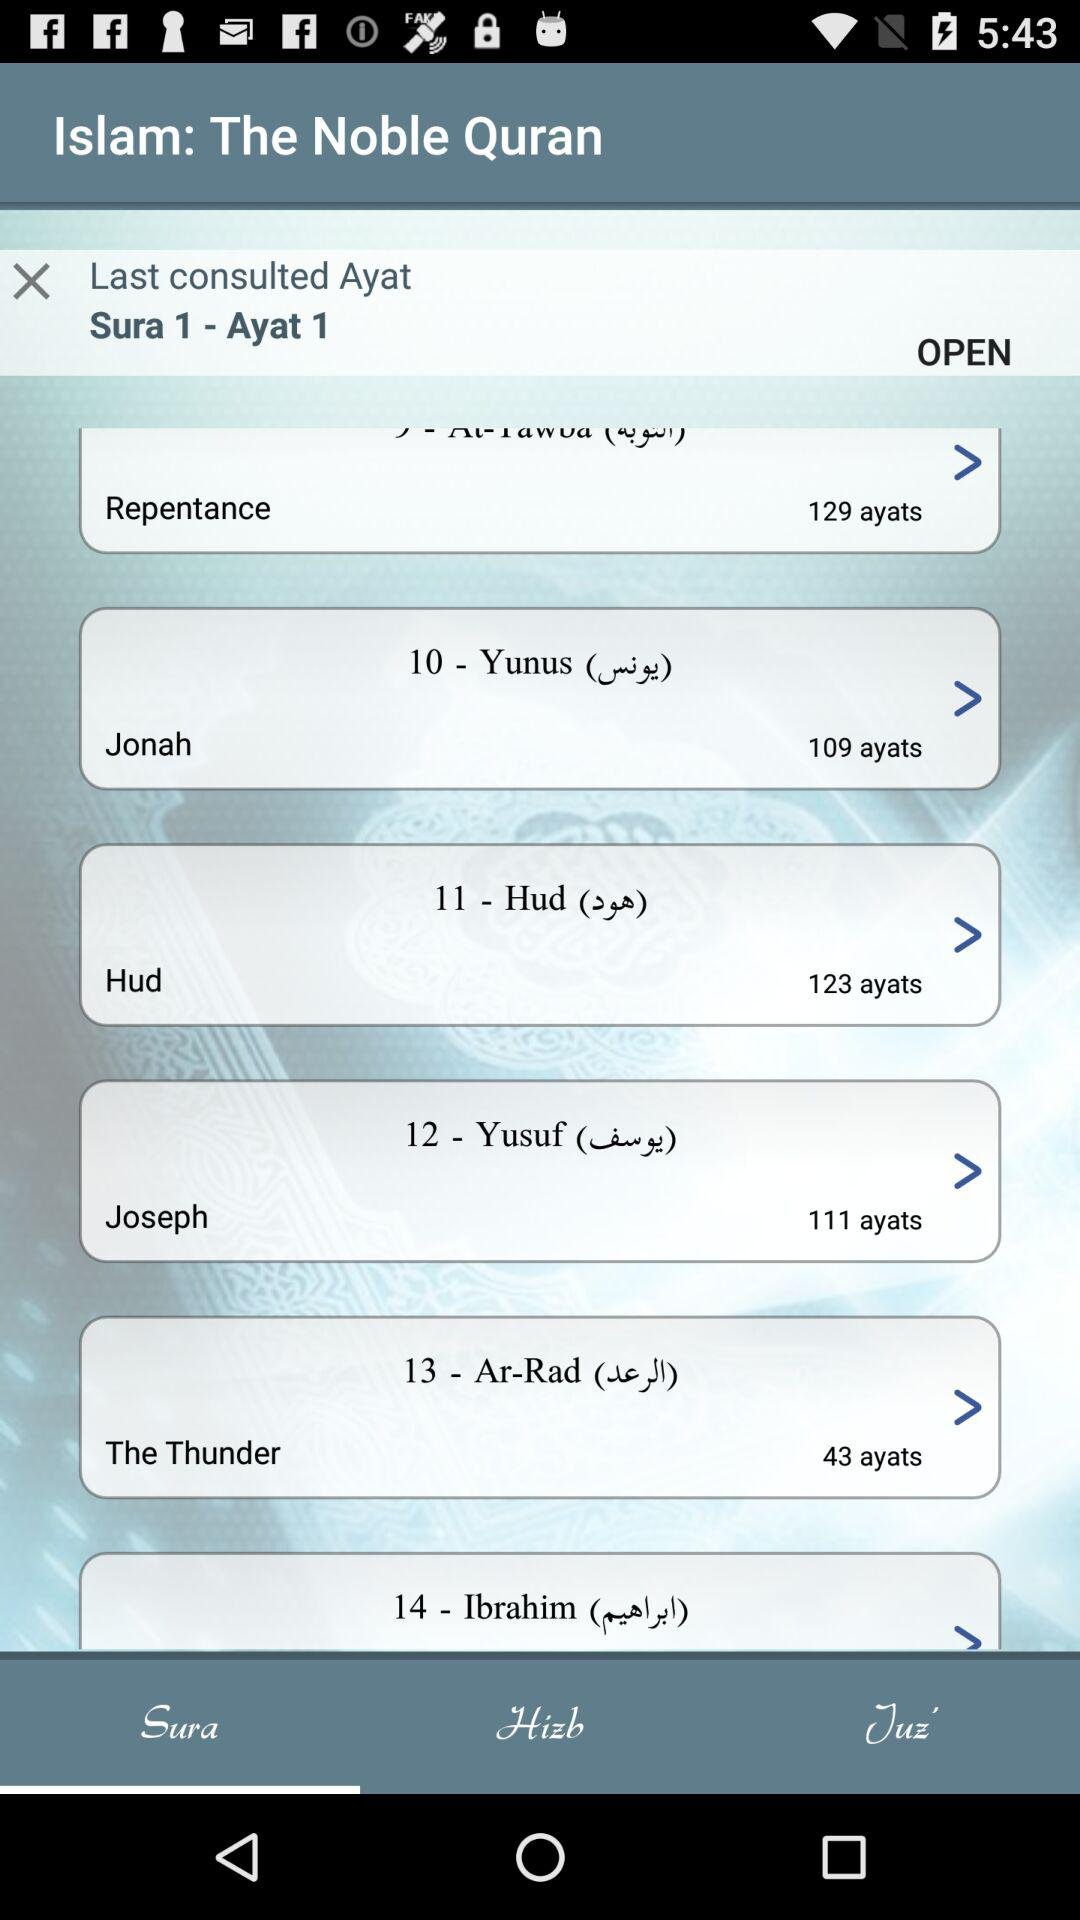What is the chapter number of "Yunus"? The chapter number of "Yunus" is 10. 